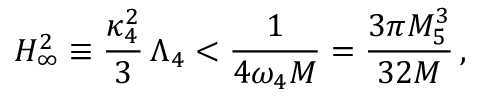Convert formula to latex. <formula><loc_0><loc_0><loc_500><loc_500>H _ { \infty } ^ { 2 } \equiv \frac { \kappa _ { 4 } ^ { 2 } } { 3 } \, \Lambda _ { 4 } < \frac { 1 } { 4 \omega _ { 4 } M } = \frac { 3 \pi M _ { 5 } ^ { 3 } } { 3 2 M } \, ,</formula> 